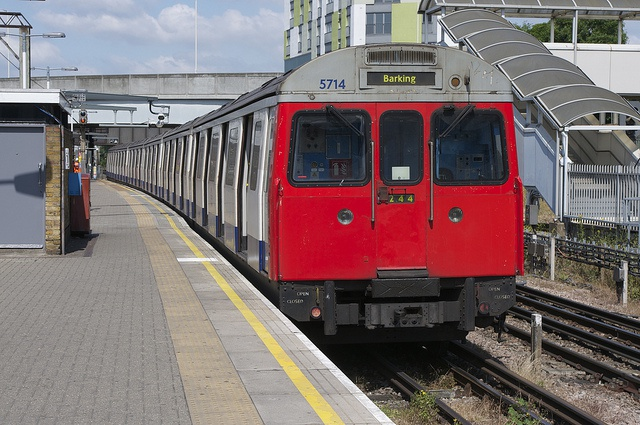Describe the objects in this image and their specific colors. I can see a train in lightblue, black, brown, and darkgray tones in this image. 